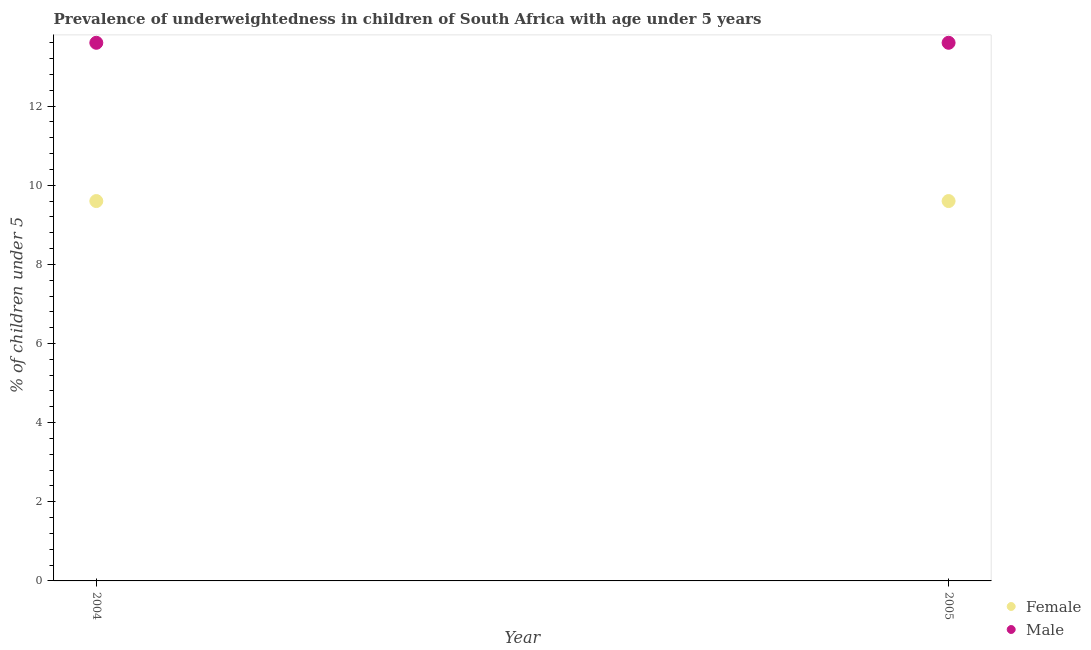Is the number of dotlines equal to the number of legend labels?
Offer a very short reply. Yes. What is the percentage of underweighted male children in 2004?
Make the answer very short. 13.6. Across all years, what is the maximum percentage of underweighted female children?
Make the answer very short. 9.6. Across all years, what is the minimum percentage of underweighted female children?
Give a very brief answer. 9.6. In which year was the percentage of underweighted male children maximum?
Ensure brevity in your answer.  2004. What is the total percentage of underweighted male children in the graph?
Your answer should be compact. 27.2. What is the difference between the percentage of underweighted male children in 2005 and the percentage of underweighted female children in 2004?
Ensure brevity in your answer.  4. What is the average percentage of underweighted female children per year?
Give a very brief answer. 9.6. In the year 2005, what is the difference between the percentage of underweighted female children and percentage of underweighted male children?
Offer a terse response. -4. In how many years, is the percentage of underweighted female children greater than 10.8 %?
Provide a short and direct response. 0. Does the percentage of underweighted male children monotonically increase over the years?
Provide a short and direct response. No. Is the percentage of underweighted male children strictly less than the percentage of underweighted female children over the years?
Keep it short and to the point. No. How many dotlines are there?
Your answer should be very brief. 2. How many years are there in the graph?
Provide a short and direct response. 2. What is the difference between two consecutive major ticks on the Y-axis?
Ensure brevity in your answer.  2. Where does the legend appear in the graph?
Your response must be concise. Bottom right. What is the title of the graph?
Your response must be concise. Prevalence of underweightedness in children of South Africa with age under 5 years. Does "Secondary school" appear as one of the legend labels in the graph?
Offer a very short reply. No. What is the label or title of the Y-axis?
Provide a short and direct response.  % of children under 5. What is the  % of children under 5 of Female in 2004?
Offer a very short reply. 9.6. What is the  % of children under 5 of Male in 2004?
Ensure brevity in your answer.  13.6. What is the  % of children under 5 of Female in 2005?
Your answer should be very brief. 9.6. What is the  % of children under 5 in Male in 2005?
Give a very brief answer. 13.6. Across all years, what is the maximum  % of children under 5 of Female?
Offer a very short reply. 9.6. Across all years, what is the maximum  % of children under 5 in Male?
Ensure brevity in your answer.  13.6. Across all years, what is the minimum  % of children under 5 in Female?
Offer a very short reply. 9.6. Across all years, what is the minimum  % of children under 5 in Male?
Offer a terse response. 13.6. What is the total  % of children under 5 of Male in the graph?
Offer a very short reply. 27.2. What is the average  % of children under 5 in Female per year?
Your answer should be very brief. 9.6. In the year 2004, what is the difference between the  % of children under 5 of Female and  % of children under 5 of Male?
Make the answer very short. -4. In the year 2005, what is the difference between the  % of children under 5 of Female and  % of children under 5 of Male?
Your answer should be very brief. -4. What is the ratio of the  % of children under 5 of Female in 2004 to that in 2005?
Give a very brief answer. 1. What is the difference between the highest and the second highest  % of children under 5 in Female?
Give a very brief answer. 0. What is the difference between the highest and the lowest  % of children under 5 in Male?
Your answer should be very brief. 0. 